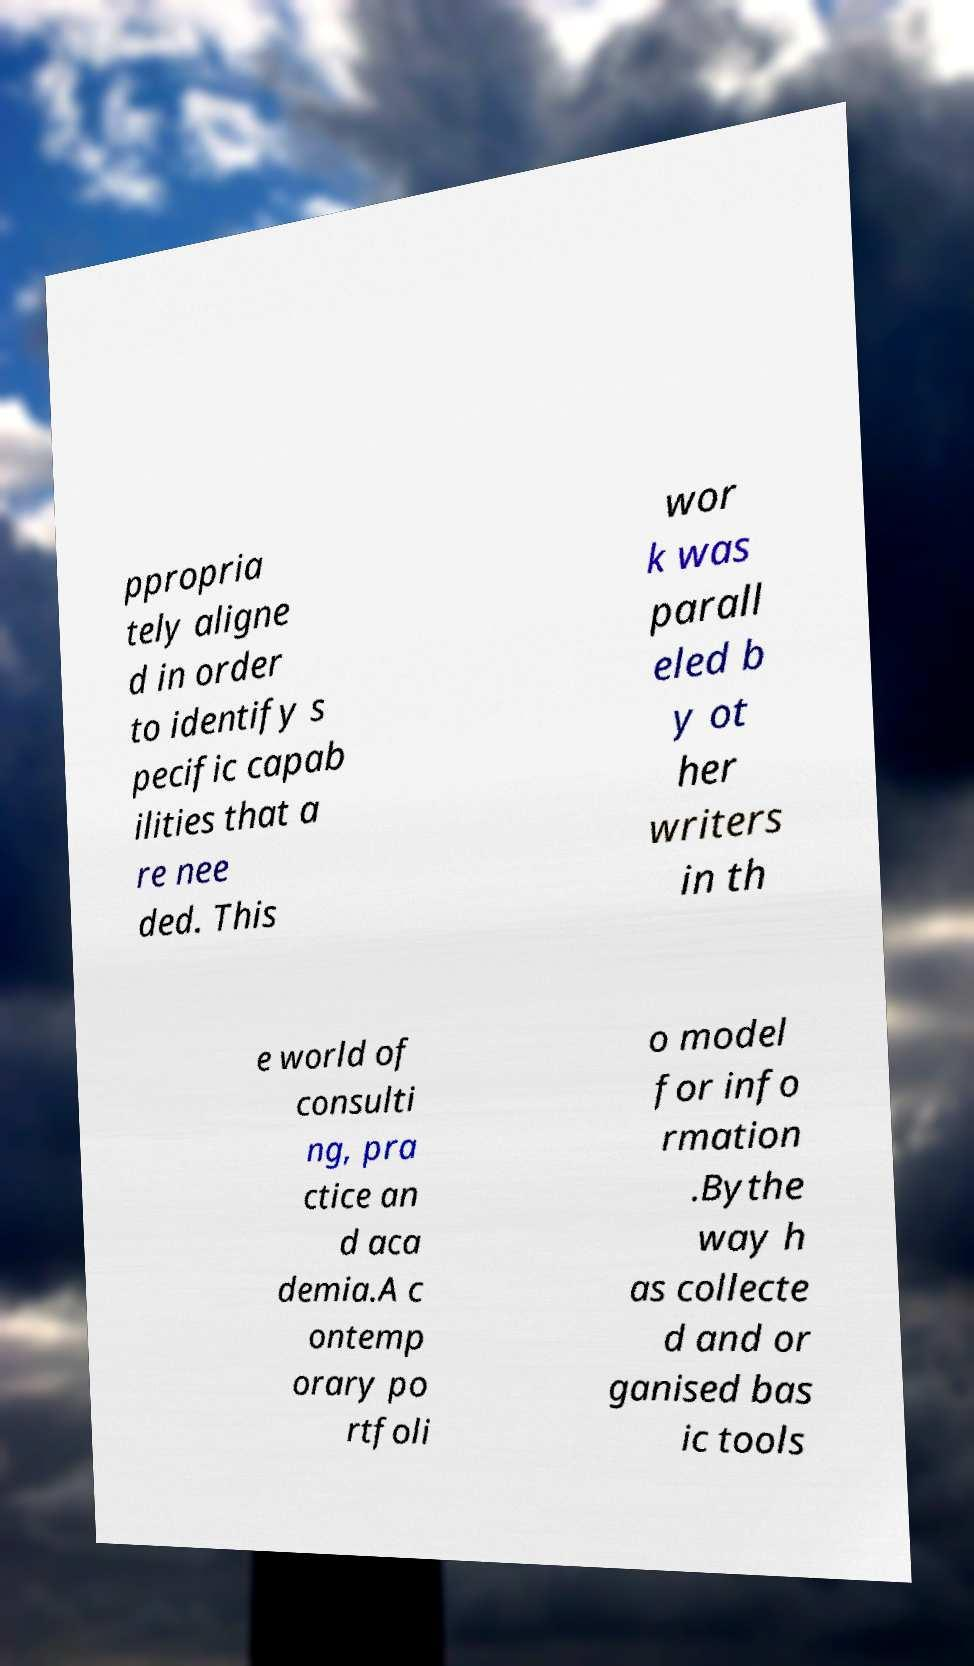For documentation purposes, I need the text within this image transcribed. Could you provide that? ppropria tely aligne d in order to identify s pecific capab ilities that a re nee ded. This wor k was parall eled b y ot her writers in th e world of consulti ng, pra ctice an d aca demia.A c ontemp orary po rtfoli o model for info rmation .Bythe way h as collecte d and or ganised bas ic tools 